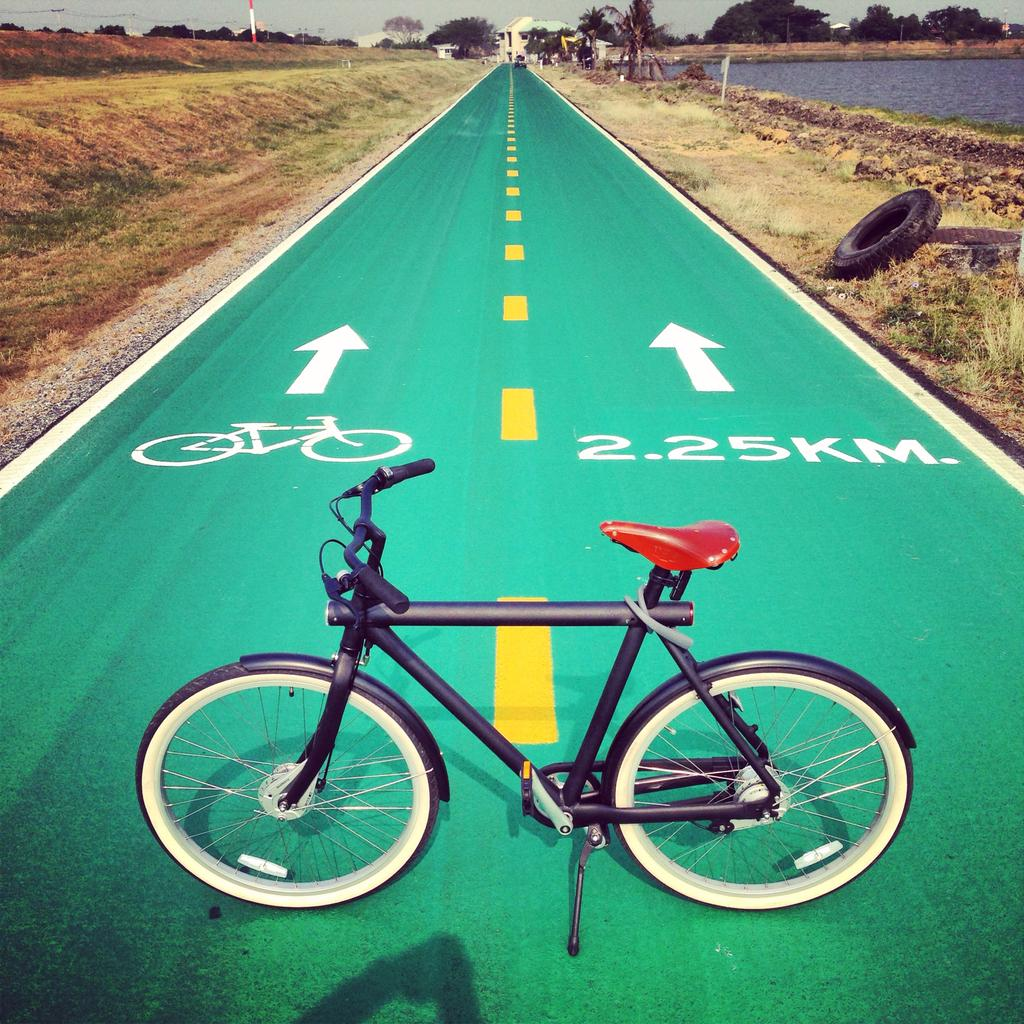What is the main object in the image? There is a bicycle in the image. What is the setting of the image? The image features a road with a margin, and there is grass visible. What can be seen in the background of the image? There are trees and a building in the background of the image. What is the condition of the bicycle? The bicycle has tires. How many bubbles are floating around the bicycle in the image? There are no bubbles present in the image. What type of spiders can be seen crawling on the bicycle in the image? There are no spiders visible on the bicycle in the image. 